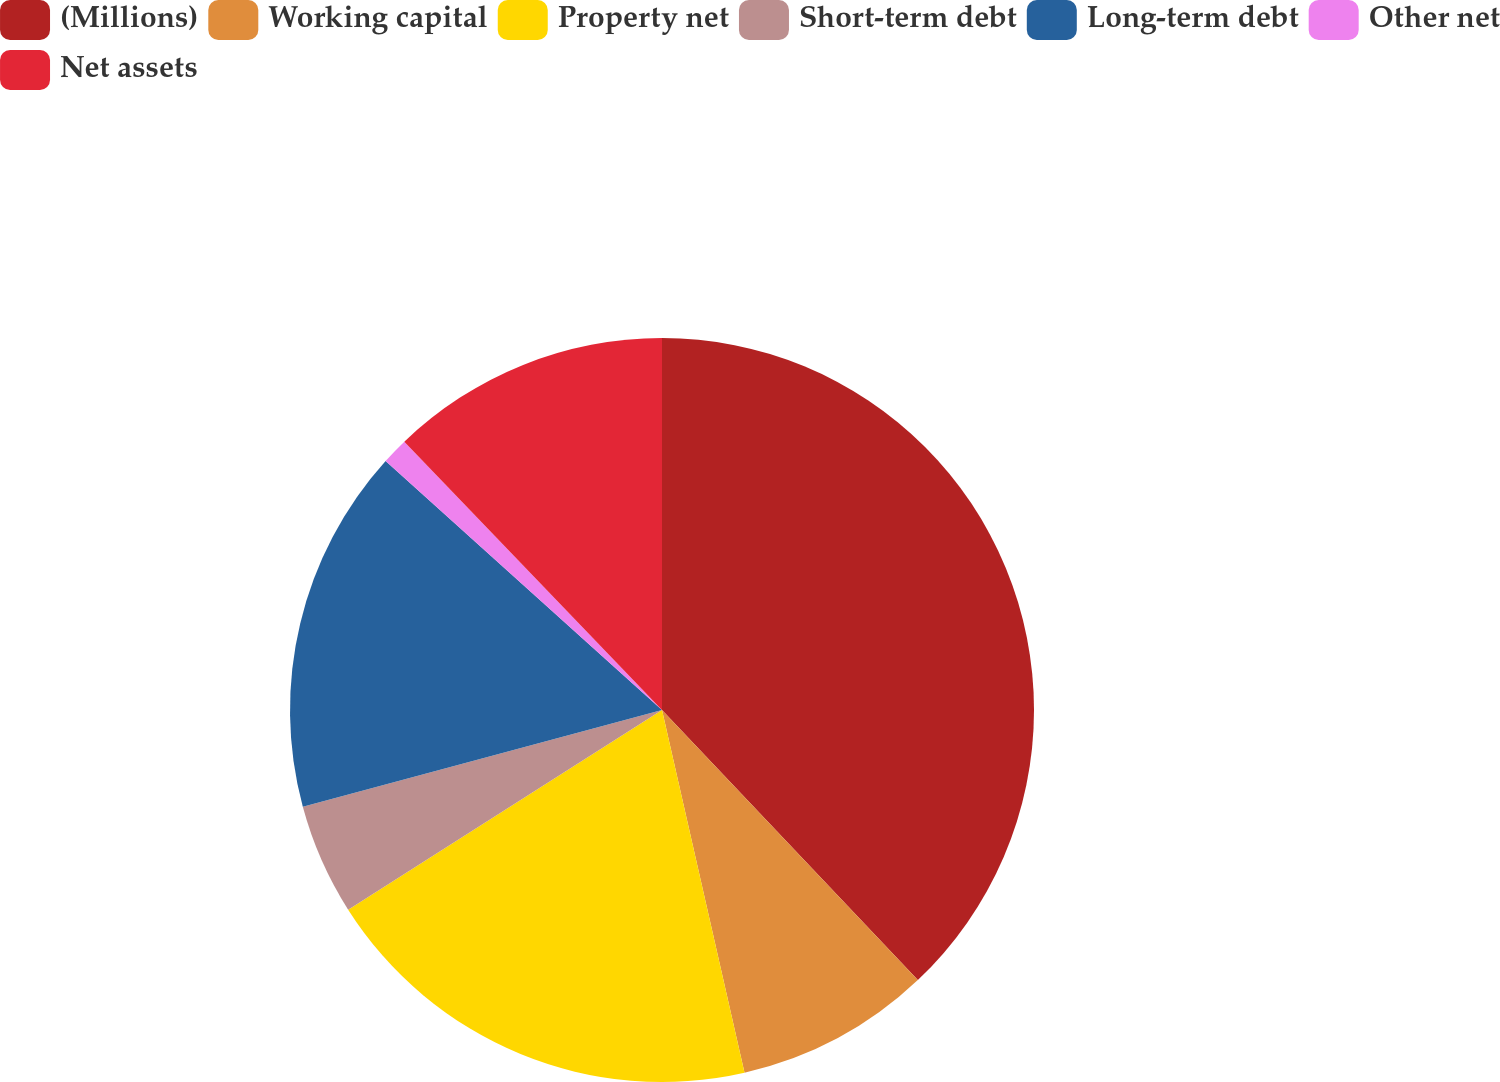Convert chart. <chart><loc_0><loc_0><loc_500><loc_500><pie_chart><fcel>(Millions)<fcel>Working capital<fcel>Property net<fcel>Short-term debt<fcel>Long-term debt<fcel>Other net<fcel>Net assets<nl><fcel>37.93%<fcel>8.51%<fcel>19.54%<fcel>4.83%<fcel>15.86%<fcel>1.15%<fcel>12.18%<nl></chart> 